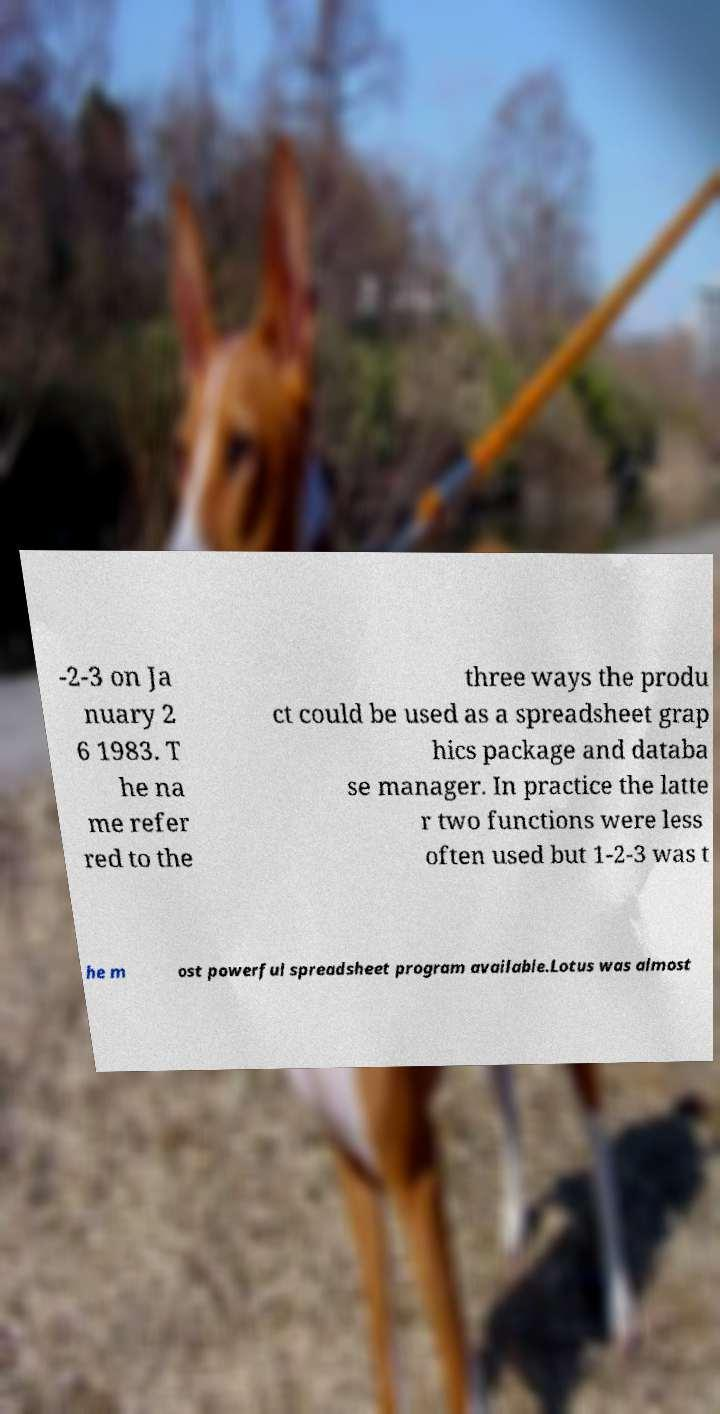Can you read and provide the text displayed in the image?This photo seems to have some interesting text. Can you extract and type it out for me? -2-3 on Ja nuary 2 6 1983. T he na me refer red to the three ways the produ ct could be used as a spreadsheet grap hics package and databa se manager. In practice the latte r two functions were less often used but 1-2-3 was t he m ost powerful spreadsheet program available.Lotus was almost 